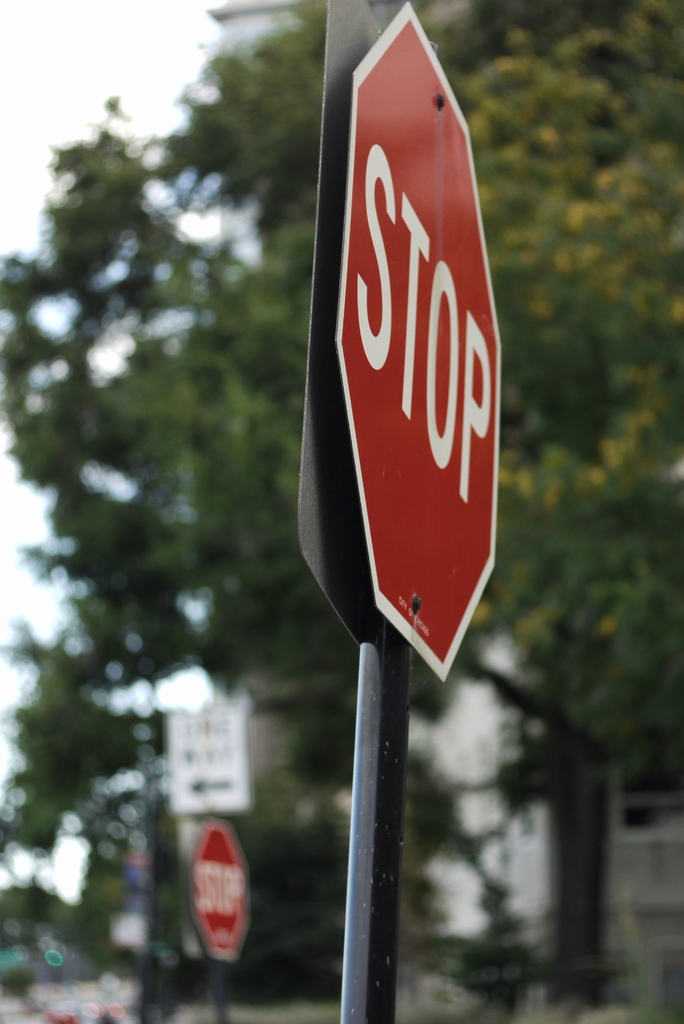Can you infer anything about the location or setting of this scene? The presence of multiple stop signs suggests an intersection or a series of intersections, indicative of an organized urban or suburban area. The white building barely visible in the background might be part of a residential or commercial district, further hinting at an organized community layout where traffic signs play a pivotal role in maintaining order and safety. 